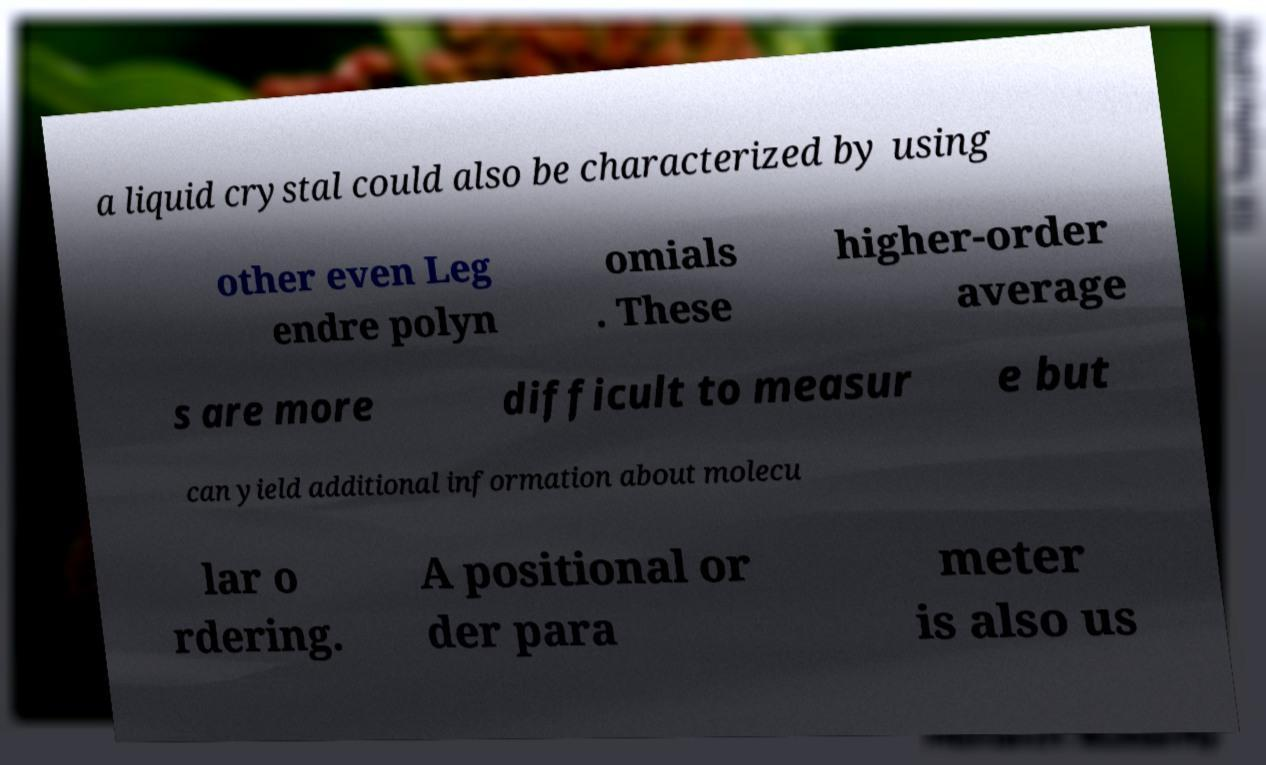There's text embedded in this image that I need extracted. Can you transcribe it verbatim? a liquid crystal could also be characterized by using other even Leg endre polyn omials . These higher-order average s are more difficult to measur e but can yield additional information about molecu lar o rdering. A positional or der para meter is also us 